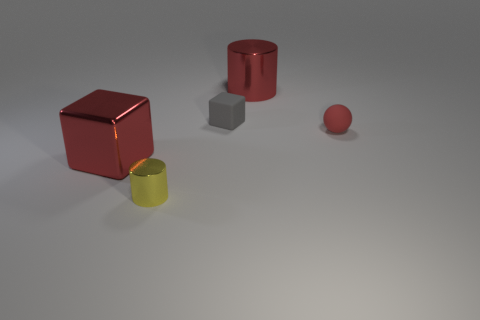There is a red block that is made of the same material as the yellow thing; what is its size?
Make the answer very short. Large. How many other tiny metallic things are the same shape as the small yellow metallic object?
Provide a succinct answer. 0. There is a metallic cylinder that is right of the tiny gray rubber object; does it have the same color as the small cube?
Your answer should be compact. No. There is a big object that is left of the small rubber thing left of the large red shiny cylinder; how many yellow metal cylinders are on the left side of it?
Offer a very short reply. 0. What number of small objects are both in front of the tiny gray rubber thing and behind the big cube?
Your answer should be compact. 1. What shape is the tiny thing that is the same color as the big shiny cylinder?
Your answer should be very brief. Sphere. Are there any other things that have the same material as the small yellow thing?
Offer a terse response. Yes. Are the yellow cylinder and the tiny gray object made of the same material?
Ensure brevity in your answer.  No. What is the shape of the gray rubber object to the right of the big metal thing that is left of the large red shiny thing behind the red rubber sphere?
Make the answer very short. Cube. Are there fewer yellow cylinders behind the big red metal cube than tiny yellow metallic cylinders that are in front of the small red object?
Offer a very short reply. Yes. 